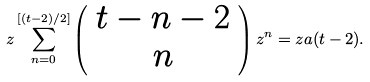Convert formula to latex. <formula><loc_0><loc_0><loc_500><loc_500>z \sum _ { n = 0 } ^ { [ ( t - 2 ) / 2 ] } \left ( \begin{array} { c } t - n - 2 \\ n \end{array} \right ) z ^ { n } = z a ( t - 2 ) .</formula> 